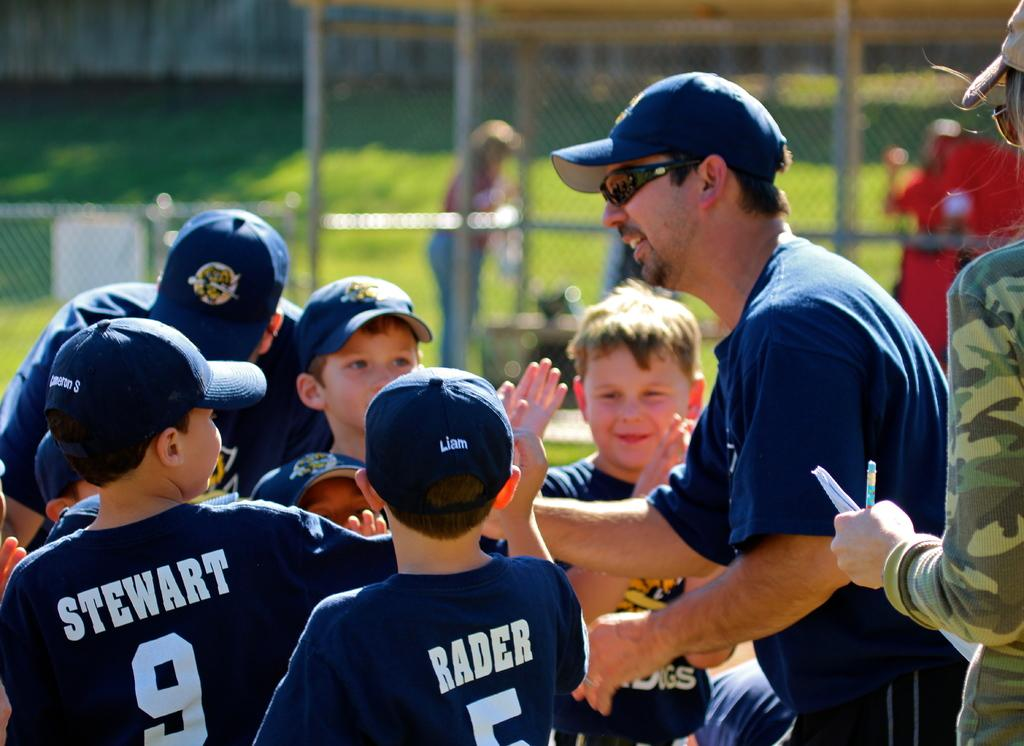<image>
Describe the image concisely. A baseball coach gives his players high fives with Stewart and Rader waiting for one. 